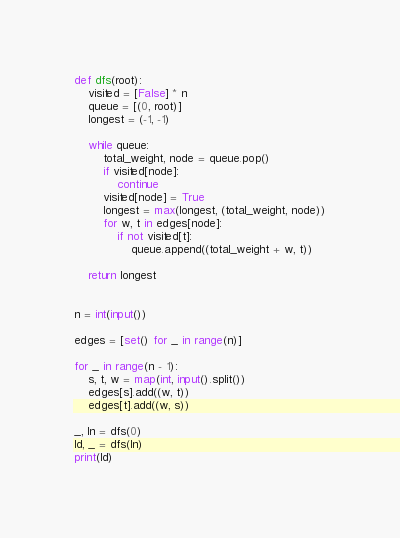Convert code to text. <code><loc_0><loc_0><loc_500><loc_500><_Python_>def dfs(root):
    visited = [False] * n
    queue = [(0, root)]
    longest = (-1, -1)

    while queue:
        total_weight, node = queue.pop()
        if visited[node]:
            continue
        visited[node] = True
        longest = max(longest, (total_weight, node))
        for w, t in edges[node]:
            if not visited[t]:
                queue.append((total_weight + w, t))

    return longest


n = int(input())

edges = [set() for _ in range(n)]

for _ in range(n - 1):
    s, t, w = map(int, input().split())
    edges[s].add((w, t))
    edges[t].add((w, s))

_, ln = dfs(0)
ld, _ = dfs(ln)
print(ld)</code> 